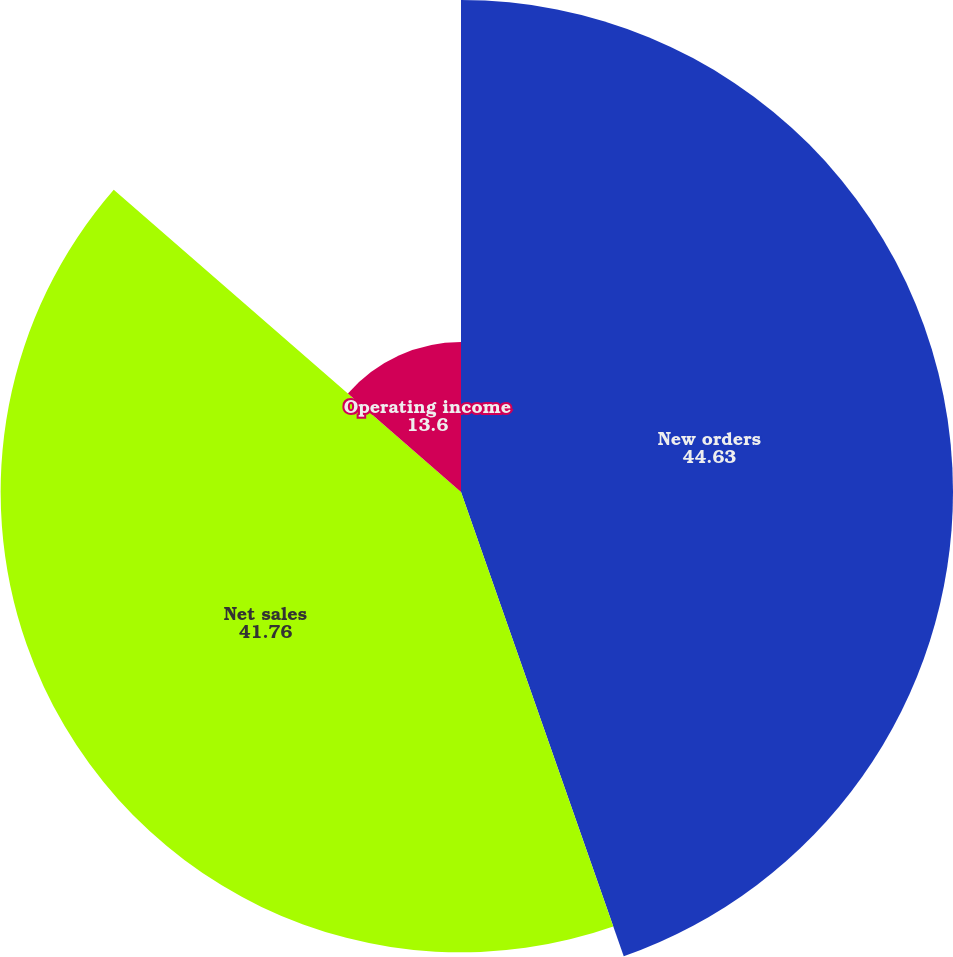<chart> <loc_0><loc_0><loc_500><loc_500><pie_chart><fcel>New orders<fcel>Net sales<fcel>Operating income<nl><fcel>44.63%<fcel>41.76%<fcel>13.6%<nl></chart> 